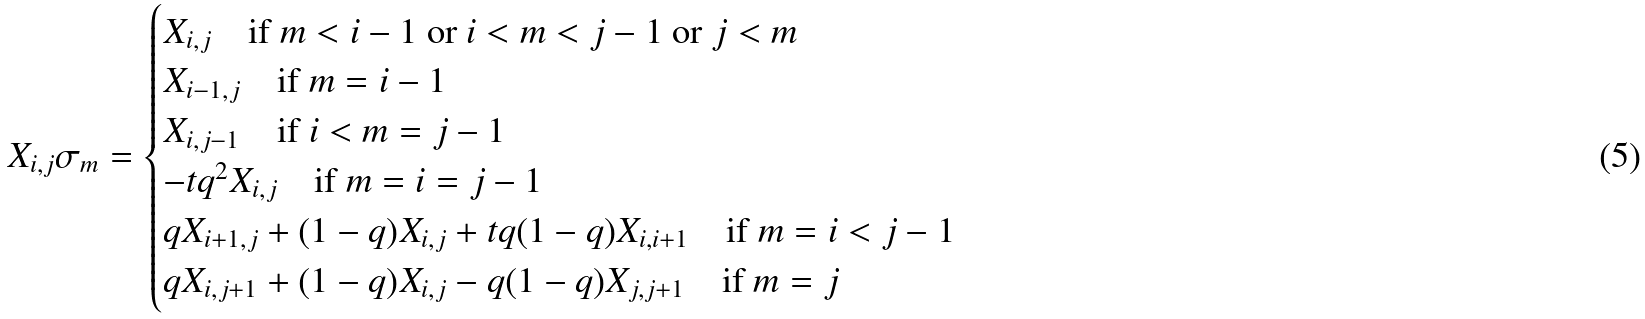Convert formula to latex. <formula><loc_0><loc_0><loc_500><loc_500>X _ { i , j } \sigma _ { m } = \begin{cases} X _ { i , j } \quad \text {if $m < i-1$ or $i<m <j-1$ or $j<m$  } \\ X _ { i - 1 , j } \quad \text {if $m = i-1$ } \, \quad \\ X _ { i , j - 1 } \quad \text {if $i< m = j-1$ } \\ - t q ^ { 2 } X _ { i , j } \quad \text {if $m=i=j-1$ } \\ q X _ { i + 1 , j } + ( 1 - q ) X _ { i , j } + t q ( 1 - q ) X _ { i , i + 1 } \quad \text {if $m=i < j-1$ } \\ q X _ { i , j + 1 } + ( 1 - q ) X _ { i , j } - q ( 1 - q ) X _ { j , j + 1 } \quad \text {if $ m = j$ } \ \quad \end{cases}</formula> 